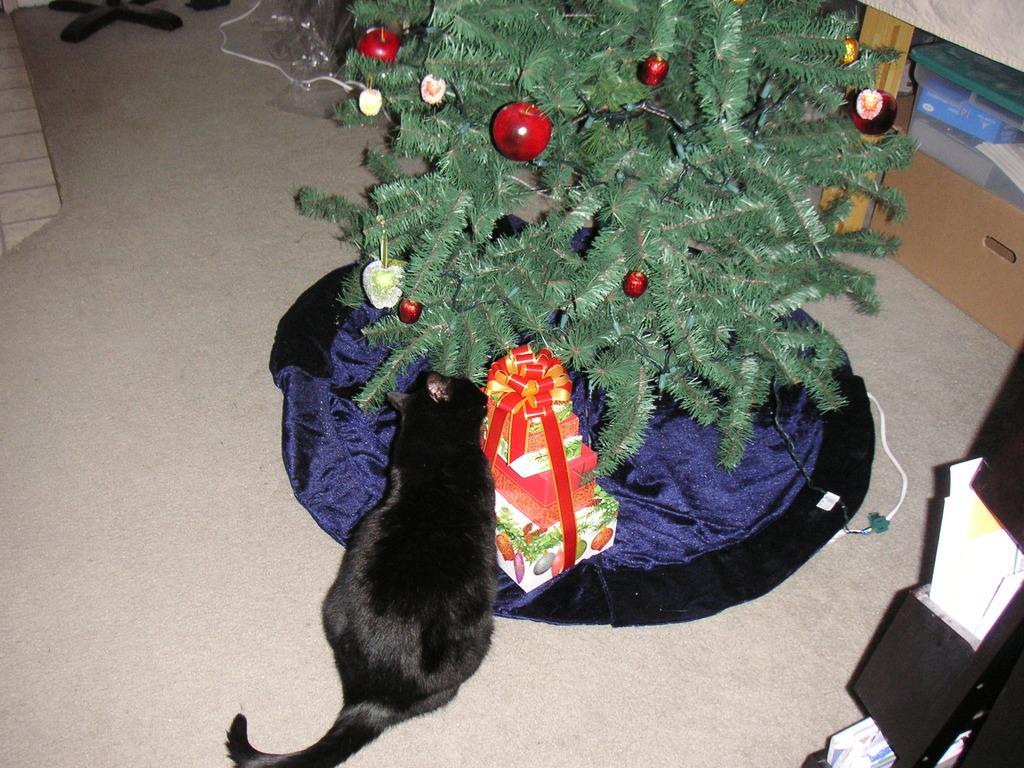Can you describe this image briefly? In the image there is a black cat sitting on floor in front of christmas tree with presents in front of it on a cloth and behind there are racks and cupboards. 